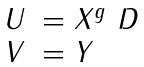Convert formula to latex. <formula><loc_0><loc_0><loc_500><loc_500>\begin{array} { l l } U & = X ^ { g } \ D \\ V & = Y \\ \end{array}</formula> 